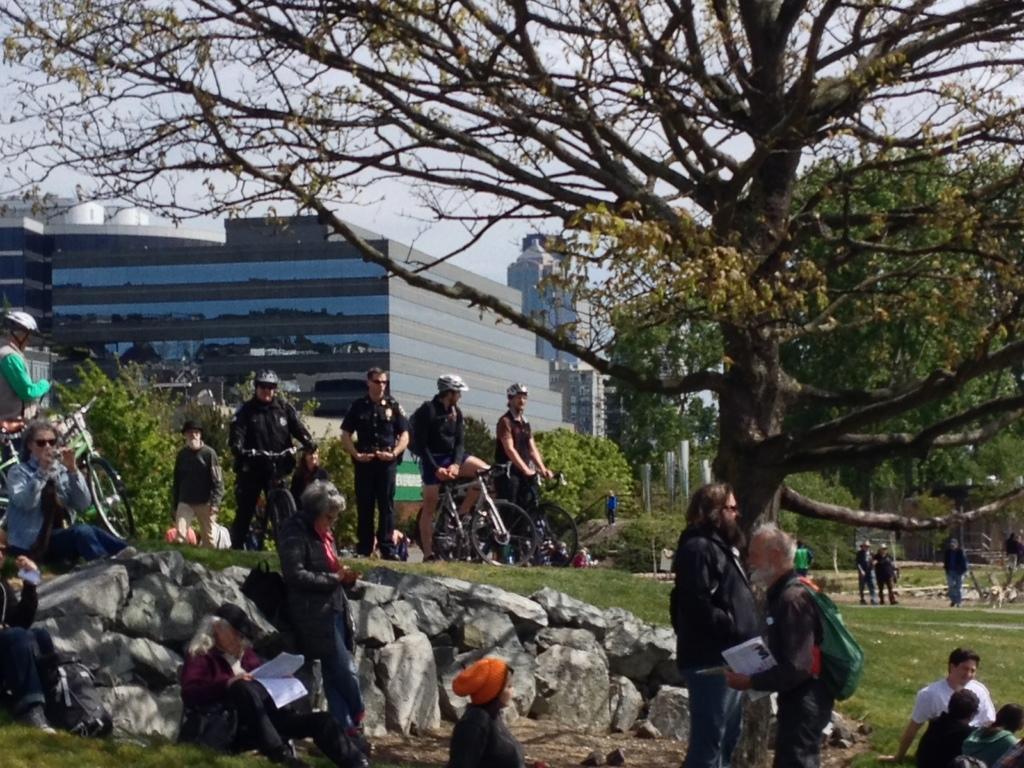Can you describe this image briefly? In this image there are a few people standing and sitting in a park on the surface of the grass, there are trees and buildings in the background of the image. 